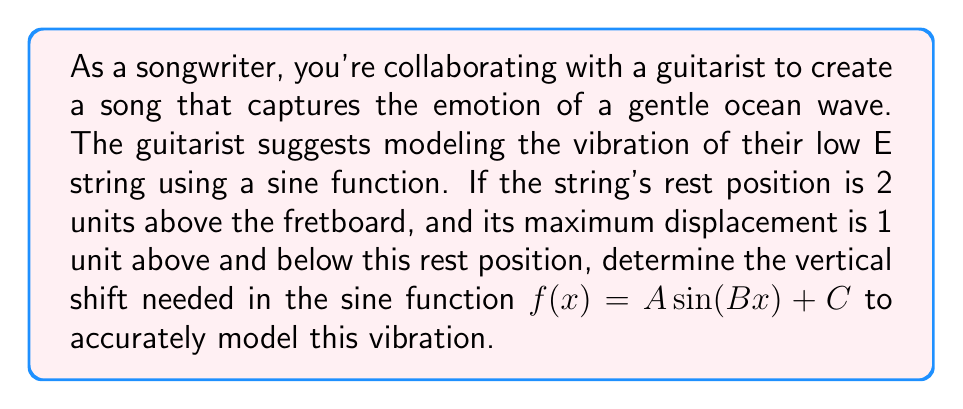Solve this math problem. To solve this problem, let's break it down step-by-step:

1) The general form of a sine function is:
   $$f(x) = A \sin(Bx) + C$$
   Where:
   - $A$ is the amplitude (half the distance between the maximum and minimum)
   - $B$ affects the period
   - $C$ is the vertical shift

2) In this case, we're only concerned with the vertical shift $C$.

3) The rest position of the string is 2 units above the fretboard. This represents the midline of the sine wave.

4) The maximum displacement is 1 unit above and below the rest position. This means:
   - The highest point of the wave is at 3 units (2 + 1)
   - The lowest point of the wave is at 1 unit (2 - 1)

5) The vertical shift $C$ in a sine function represents the y-coordinate of the midline of the wave.

6) Since the rest position (midline) is 2 units above the fretboard, the vertical shift $C$ should be 2.

Therefore, to model this guitar string vibration, we need a vertical shift of 2 units upward from the standard sine function.
Answer: The vertical shift needed is $C = 2$. 